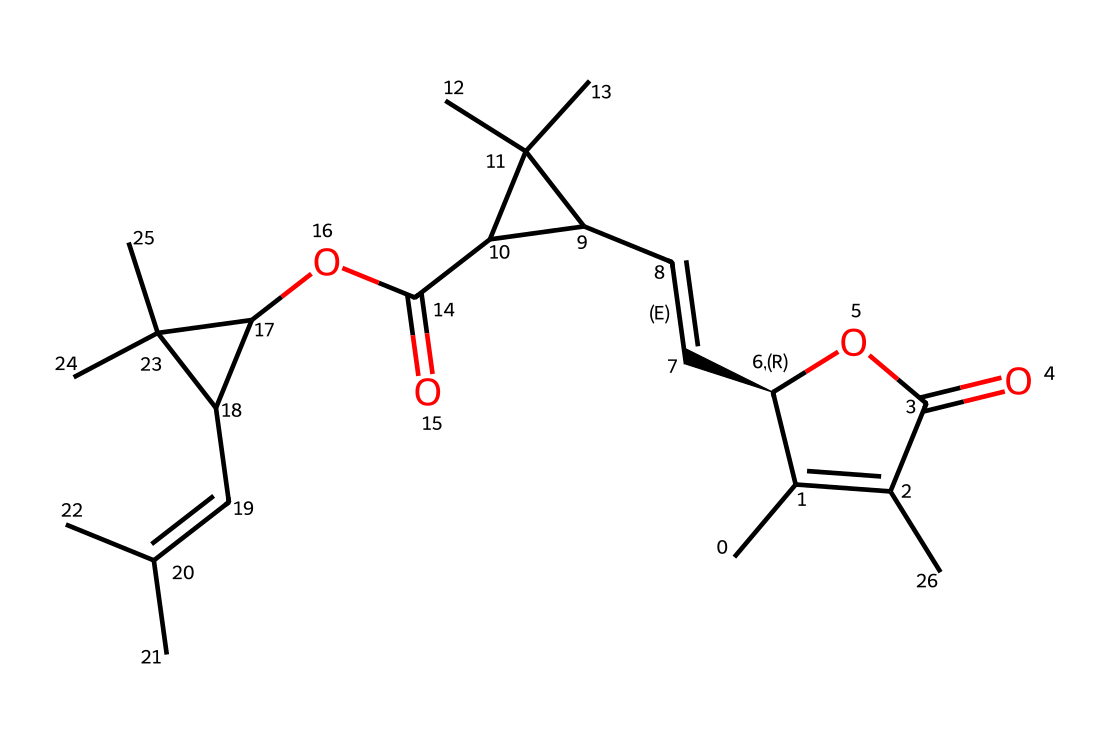What is the main functional group present in this compound? The structure contains an ester group indicated by the presence of -O- followed by a carbonyl (C=O) adjacent to the oxygen.
Answer: ester How many rings are present in the molecular structure? By analyzing the structure carefully, there are three cyclical structures formed, identifiable by the interconnected carbon atoms that create the rings.
Answer: three What type of stereochemistry is indicated in this molecule? The notation [C@@H] indicates one chiral center, suggesting that this part of the molecule has specific stereochemistry with one enantiomeric configuration.
Answer: chiral Which natural source is this insecticide derived from? The SMILES representation mentions natural insecticides derived from chrysanthemum flowers, which are known to produce pyrethrins.
Answer: chrysanthemum What is the primary use of pyrethrins in agriculture? Pyrethrins are primarily used as insecticides due to their ability to target and disrupt the nervous systems of insects.
Answer: insecticides How many total carbon atoms are present in the structure? By counting the carbon atoms represented in the SMILES notation, the total count yields 30 carbon atoms in the entire structure.
Answer: thirty 